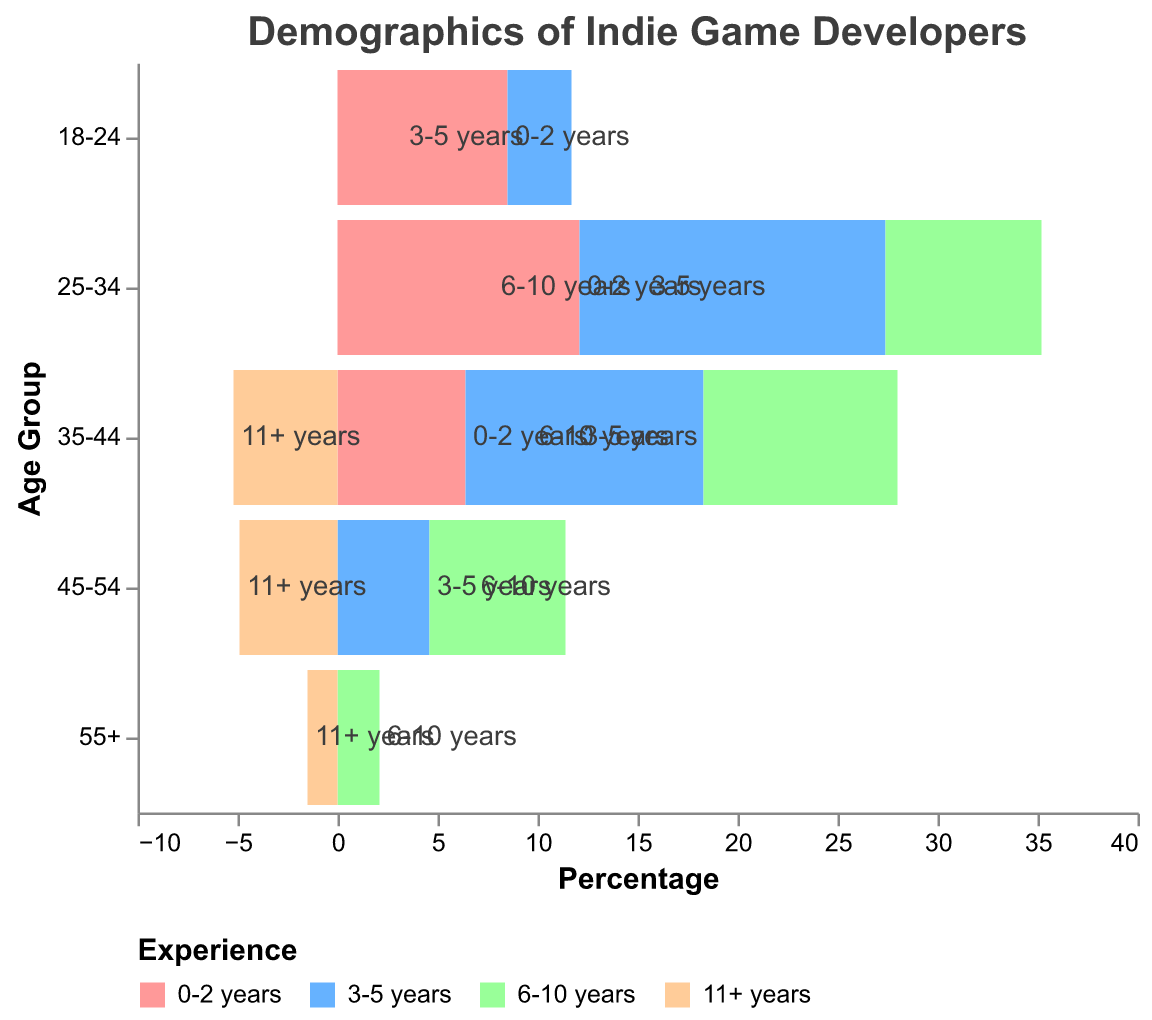What is the title of the figure? The title of the figure is typically found at the top, and it provides a summary of what the chart depicts. In this case, it's relatively simple to identify.
Answer: Demographics of Indie Game Developers Which age group has the highest percentage of developers with 3-5 years of experience? To find this, look at the bars representing the 3-5 years of experience category and identify the one with the highest percentage.
Answer: 25-34 How many age groups are represented in the figure? Count the unique age groups listed on the y-axis.
Answer: 5 What is the percentage of 35-44 age group with 6-10 years of experience? Locate the bar that corresponds to the 35-44 age group and 6-10 years of experience, and read its percentage value.
Answer: 9.7% Which age group has the least representation in terms of developers with 11+ years of experience? Look at the bars for the 11+ years of experience category and find the one with the smallest percentage.
Answer: 55+ What is the difference in the percentage of developers aged 18-24 between 0-2 years and 3-5 years of experience? Subtract the percentage of the 3-5 years experience from the percentage of the 0-2 years experience for the 18-24 age group.
Answer: 5.3% Which age group has the largest variety of experience levels represented? Count the distinct experience categories for each age group and find the one with the highest count.
Answer: 35-44 Which age group has a higher percentage of developers with 0-2 years of experience, 18-24 or 25-34? Compare the percentages for 0-2 years of experience between these age groups.
Answer: 25-34 What is the total percentage of developers aged 45-54 with 6-10 years and 11+ years of experience combined? Add the percentages for 6-10 years and 11+ years of experience for the 45-54 age group.
Answer: 11.7% Compare the percentage of developers aged 25-34 with 6-10 years of experience to those aged 35-44 with 11+ years of experience. Which is higher? Look at the percentages for 25-34 with 6-10 years and 35-44 with 11+ years, then compare these values.
Answer: 25-34 with 6-10 years 